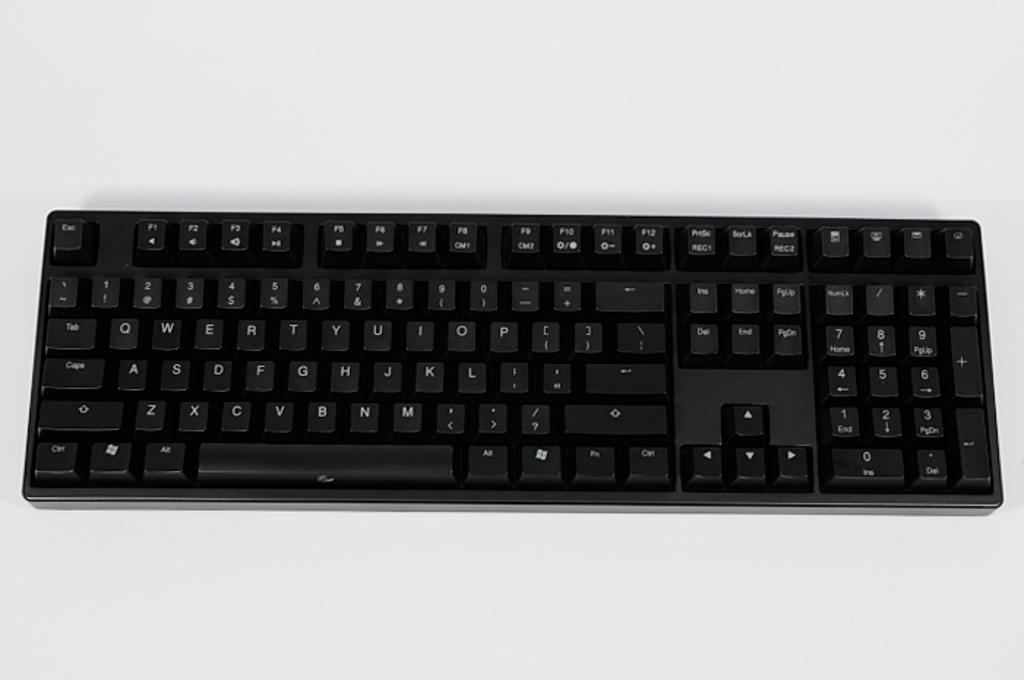<image>
Write a terse but informative summary of the picture. A black computer keyboard with a number of keys including Esc. 